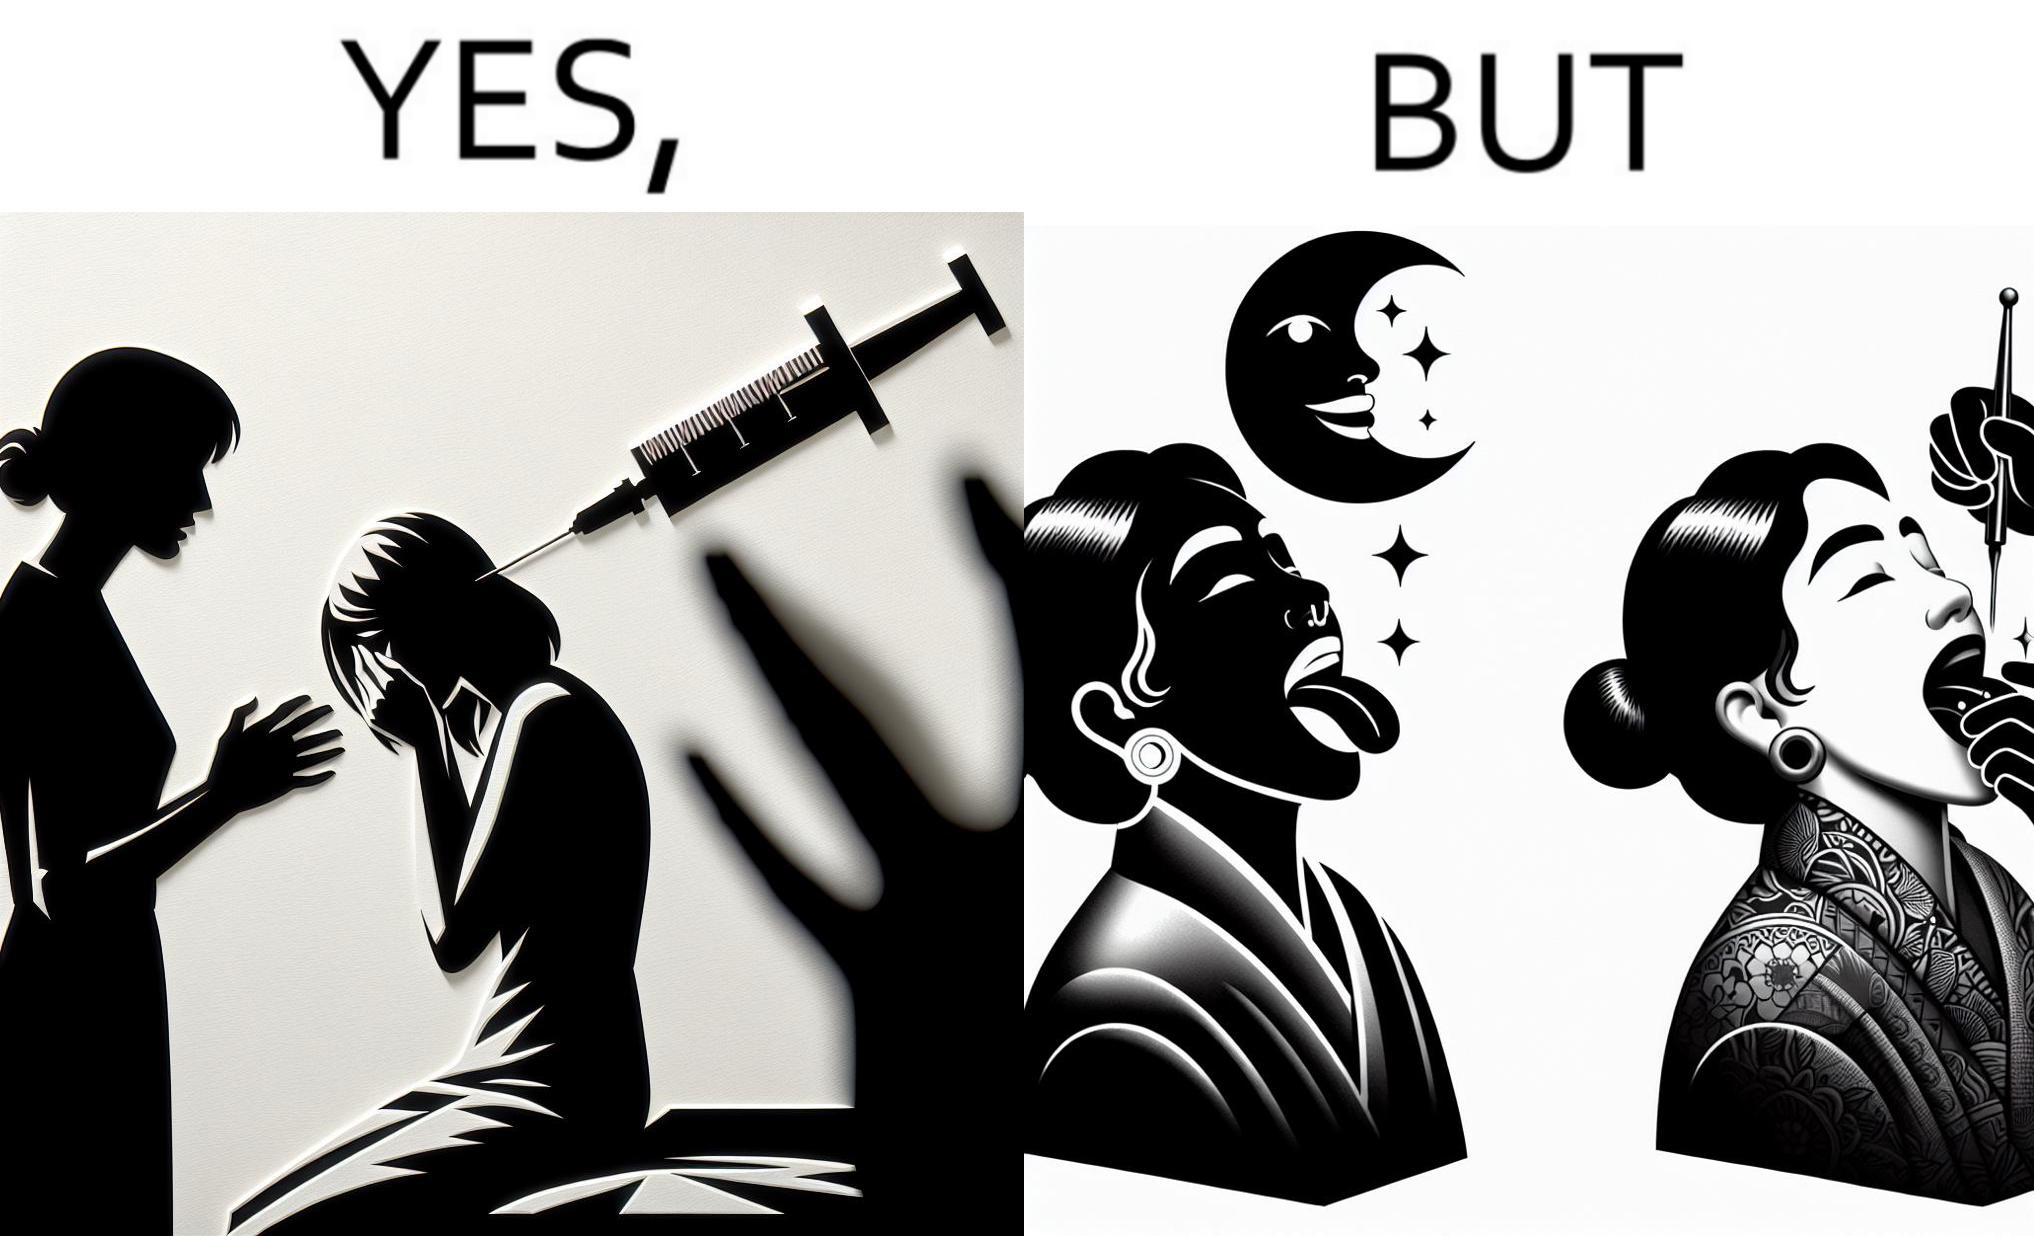Describe the content of this image. The image is funny becuase while the woman is scared of getting an injection which is for her benefit, she is not afraid of getting a piercing or a tattoo which are not going to help her in any way. 